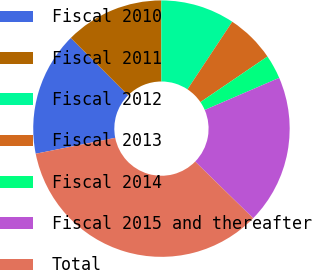<chart> <loc_0><loc_0><loc_500><loc_500><pie_chart><fcel>Fiscal 2010<fcel>Fiscal 2011<fcel>Fiscal 2012<fcel>Fiscal 2013<fcel>Fiscal 2014<fcel>Fiscal 2015 and thereafter<fcel>Total<nl><fcel>15.64%<fcel>12.48%<fcel>9.33%<fcel>6.18%<fcel>3.03%<fcel>18.79%<fcel>34.55%<nl></chart> 